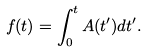<formula> <loc_0><loc_0><loc_500><loc_500>f ( t ) = \int _ { 0 } ^ { t } A ( t ^ { \prime } ) d t ^ { \prime } .</formula> 